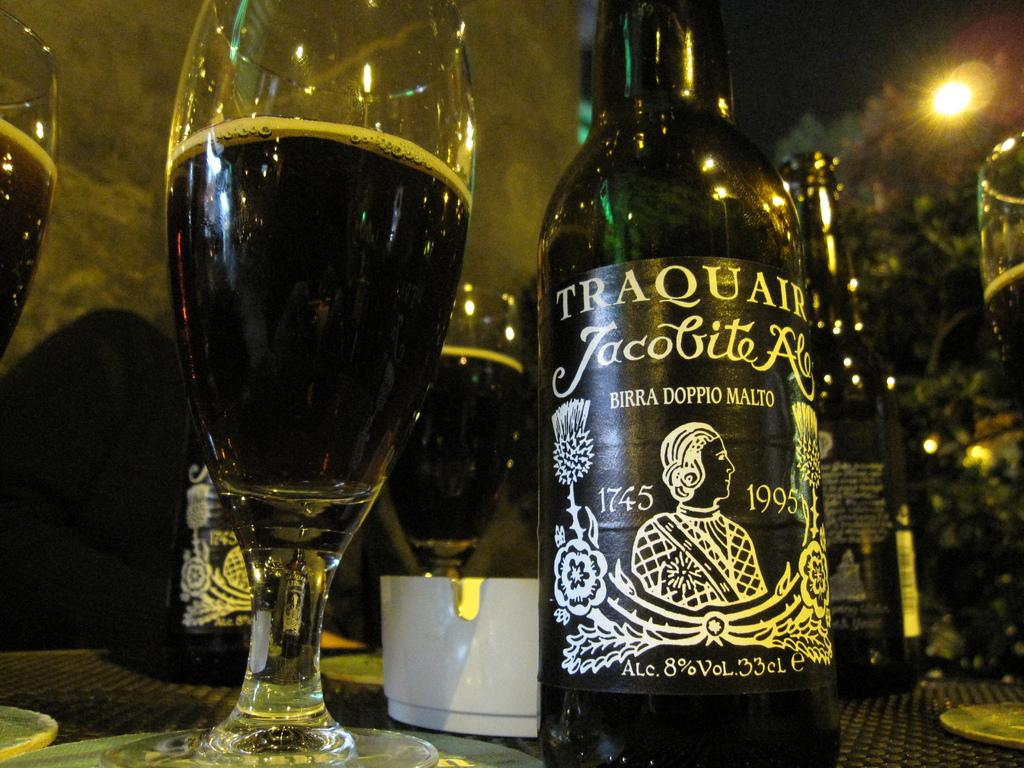What is that drink?
Keep it short and to the point. Traquair. What are the years on the bottle?
Your answer should be very brief. 1745 1995. 